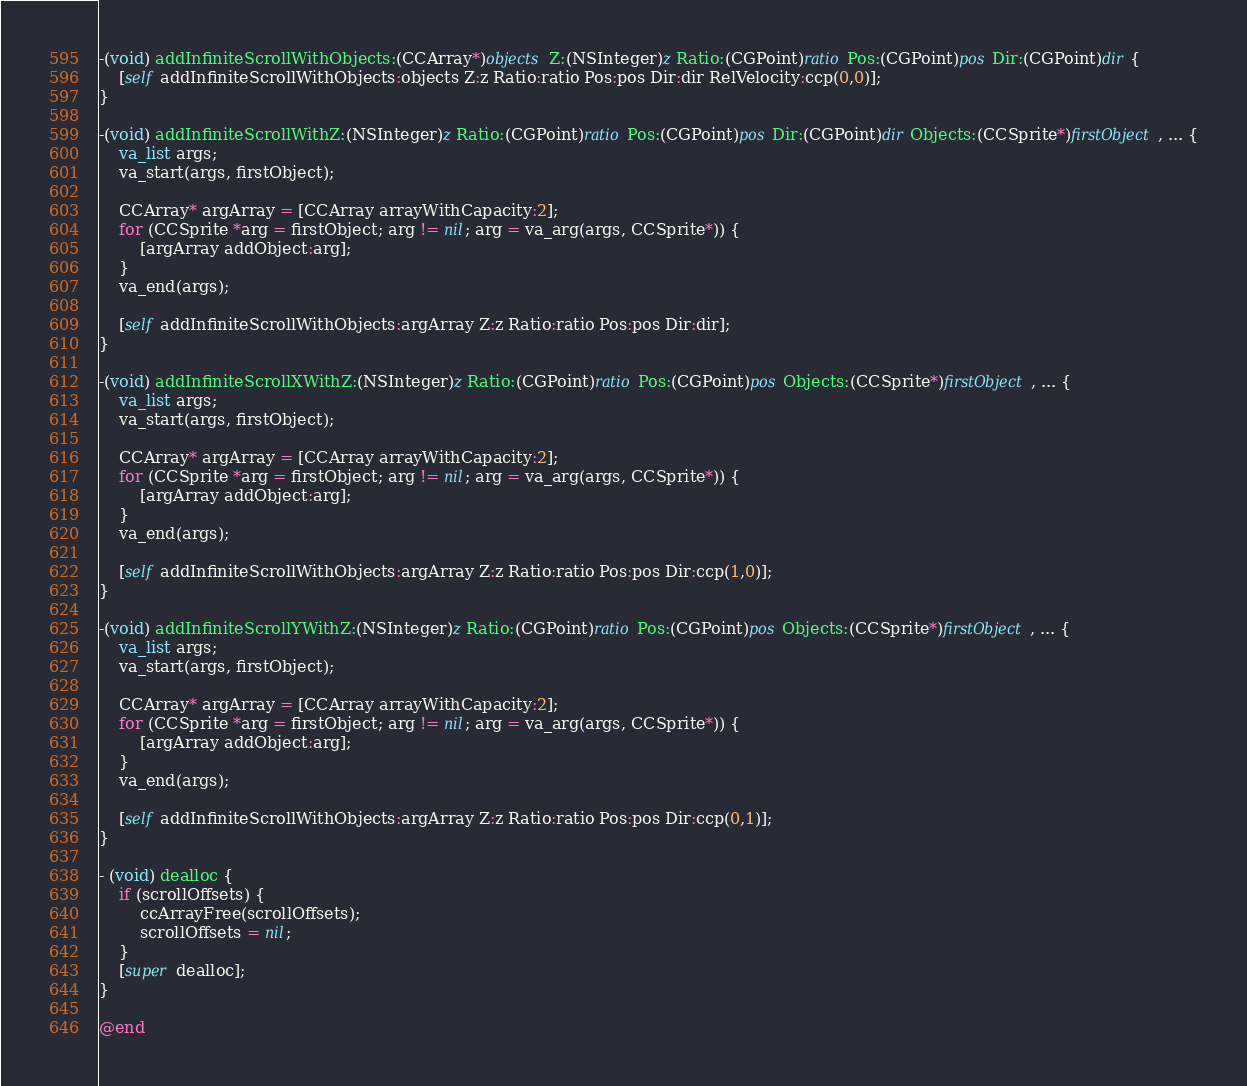<code> <loc_0><loc_0><loc_500><loc_500><_ObjectiveC_>-(void) addInfiniteScrollWithObjects:(CCArray*)objects Z:(NSInteger)z Ratio:(CGPoint)ratio Pos:(CGPoint)pos Dir:(CGPoint)dir {
	[self addInfiniteScrollWithObjects:objects Z:z Ratio:ratio Pos:pos Dir:dir RelVelocity:ccp(0,0)];
}

-(void) addInfiniteScrollWithZ:(NSInteger)z Ratio:(CGPoint)ratio Pos:(CGPoint)pos Dir:(CGPoint)dir Objects:(CCSprite*)firstObject, ... {
	va_list args;
    va_start(args, firstObject);
	
	CCArray* argArray = [CCArray arrayWithCapacity:2];
	for (CCSprite *arg = firstObject; arg != nil; arg = va_arg(args, CCSprite*)) {
		[argArray addObject:arg];
	}
	va_end(args);
	
	[self addInfiniteScrollWithObjects:argArray Z:z Ratio:ratio Pos:pos Dir:dir];
}

-(void) addInfiniteScrollXWithZ:(NSInteger)z Ratio:(CGPoint)ratio Pos:(CGPoint)pos Objects:(CCSprite*)firstObject, ... {
	va_list args;
    va_start(args, firstObject);
	
	CCArray* argArray = [CCArray arrayWithCapacity:2];
	for (CCSprite *arg = firstObject; arg != nil; arg = va_arg(args, CCSprite*)) {
		[argArray addObject:arg];
	}
	va_end(args);
	
	[self addInfiniteScrollWithObjects:argArray Z:z Ratio:ratio Pos:pos Dir:ccp(1,0)];
}

-(void) addInfiniteScrollYWithZ:(NSInteger)z Ratio:(CGPoint)ratio Pos:(CGPoint)pos Objects:(CCSprite*)firstObject, ... {
	va_list args;
    va_start(args, firstObject);
	
	CCArray* argArray = [CCArray arrayWithCapacity:2];
	for (CCSprite *arg = firstObject; arg != nil; arg = va_arg(args, CCSprite*)) {
		[argArray addObject:arg];
	}
	va_end(args);
	
	[self addInfiniteScrollWithObjects:argArray Z:z Ratio:ratio Pos:pos Dir:ccp(0,1)];
}

- (void) dealloc {
	if (scrollOffsets) {
		ccArrayFree(scrollOffsets);
		scrollOffsets = nil;
	}
	[super dealloc];
}

@end
</code> 